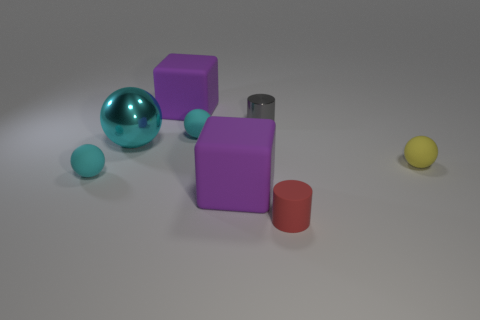Do the red object and the yellow sphere have the same material?
Provide a short and direct response. Yes. How many other things are the same material as the small gray object?
Give a very brief answer. 1. Is the number of cylinders greater than the number of metal cylinders?
Your answer should be compact. Yes. Does the small cyan rubber thing that is on the right side of the large cyan shiny thing have the same shape as the large cyan shiny thing?
Your answer should be compact. Yes. Is the number of blocks less than the number of matte things?
Your response must be concise. Yes. What material is the other gray cylinder that is the same size as the matte cylinder?
Provide a short and direct response. Metal. There is a tiny matte cylinder; is its color the same as the tiny rubber ball behind the big sphere?
Keep it short and to the point. No. Is the number of red matte objects that are in front of the small red rubber thing less than the number of gray matte cylinders?
Give a very brief answer. No. What number of purple things are there?
Ensure brevity in your answer.  2. There is a object that is right of the rubber cylinder on the right side of the tiny gray shiny cylinder; what shape is it?
Your answer should be very brief. Sphere. 